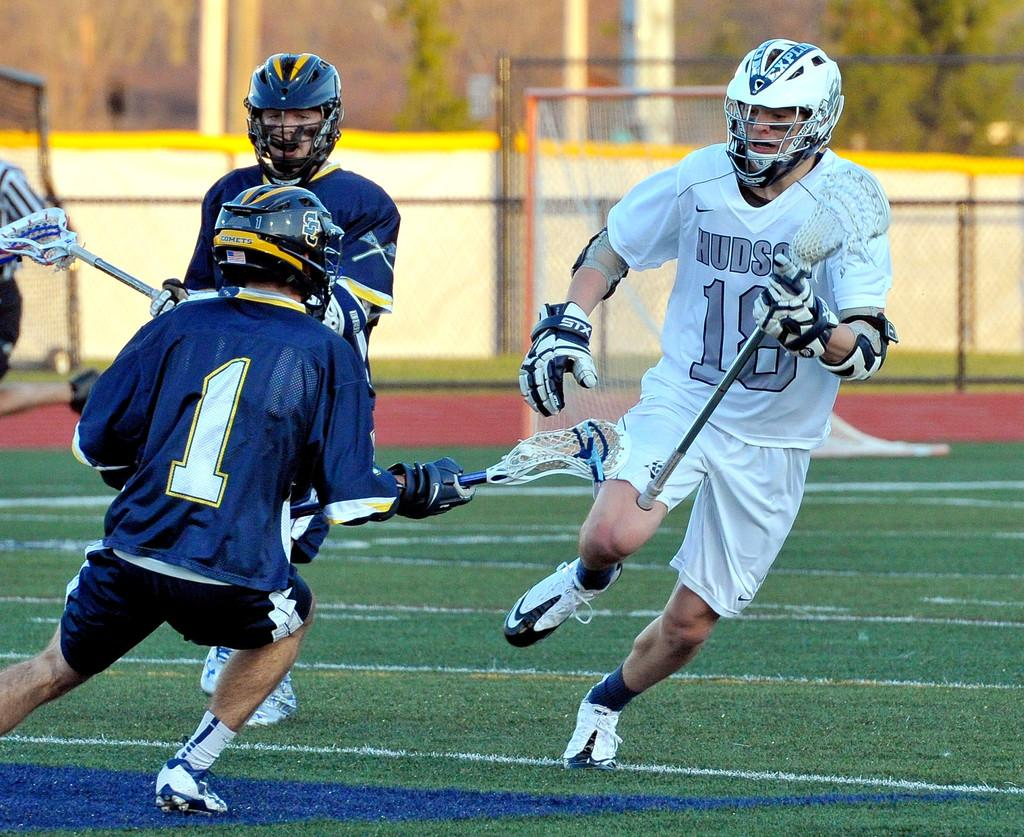What activity are the people in the image engaged in? The people in the image are playing a sport. What type of surface is the sport being played on? The sport is being played on grass. What can be seen in the background of the image? There is a wall in the background of the image. What behavioral theory is being demonstrated by the people in the image? There is no behavioral theory being demonstrated in the image; it simply shows people playing a sport on grass. 